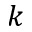Convert formula to latex. <formula><loc_0><loc_0><loc_500><loc_500>k</formula> 